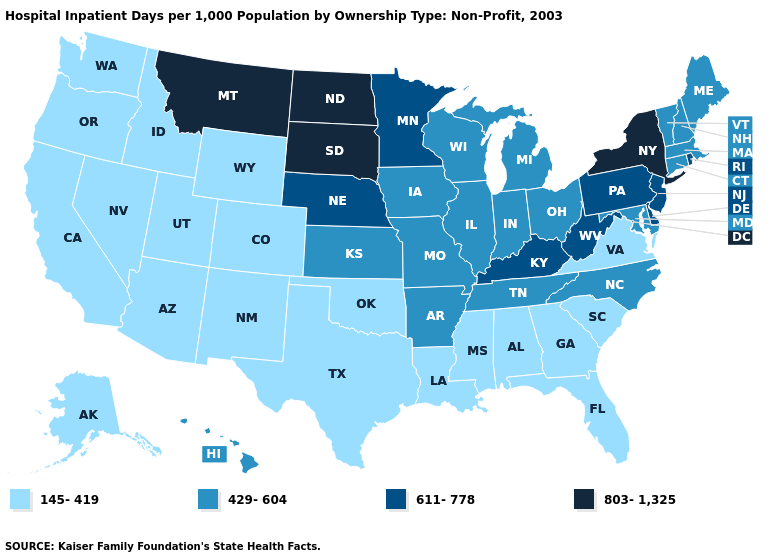Does New Mexico have the lowest value in the USA?
Give a very brief answer. Yes. What is the lowest value in states that border South Carolina?
Short answer required. 145-419. Which states hav the highest value in the Northeast?
Answer briefly. New York. Which states have the lowest value in the MidWest?
Keep it brief. Illinois, Indiana, Iowa, Kansas, Michigan, Missouri, Ohio, Wisconsin. Does California have the lowest value in the USA?
Keep it brief. Yes. What is the lowest value in states that border Pennsylvania?
Write a very short answer. 429-604. Name the states that have a value in the range 803-1,325?
Answer briefly. Montana, New York, North Dakota, South Dakota. What is the value of Rhode Island?
Quick response, please. 611-778. What is the highest value in the West ?
Keep it brief. 803-1,325. Name the states that have a value in the range 145-419?
Quick response, please. Alabama, Alaska, Arizona, California, Colorado, Florida, Georgia, Idaho, Louisiana, Mississippi, Nevada, New Mexico, Oklahoma, Oregon, South Carolina, Texas, Utah, Virginia, Washington, Wyoming. What is the lowest value in the South?
Answer briefly. 145-419. Name the states that have a value in the range 145-419?
Keep it brief. Alabama, Alaska, Arizona, California, Colorado, Florida, Georgia, Idaho, Louisiana, Mississippi, Nevada, New Mexico, Oklahoma, Oregon, South Carolina, Texas, Utah, Virginia, Washington, Wyoming. Does Colorado have the lowest value in the West?
Short answer required. Yes. What is the value of New Hampshire?
Write a very short answer. 429-604. Among the states that border Mississippi , does Arkansas have the lowest value?
Be succinct. No. 